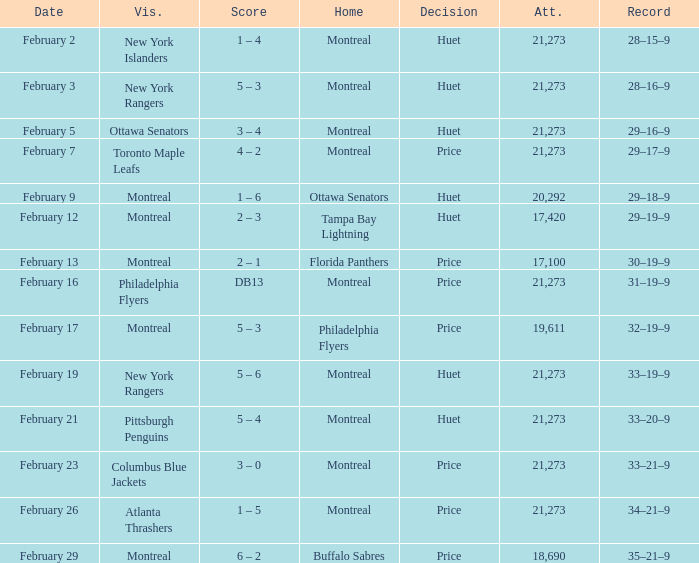What was the date of the game when the Canadiens had a record of 31–19–9? February 16. 